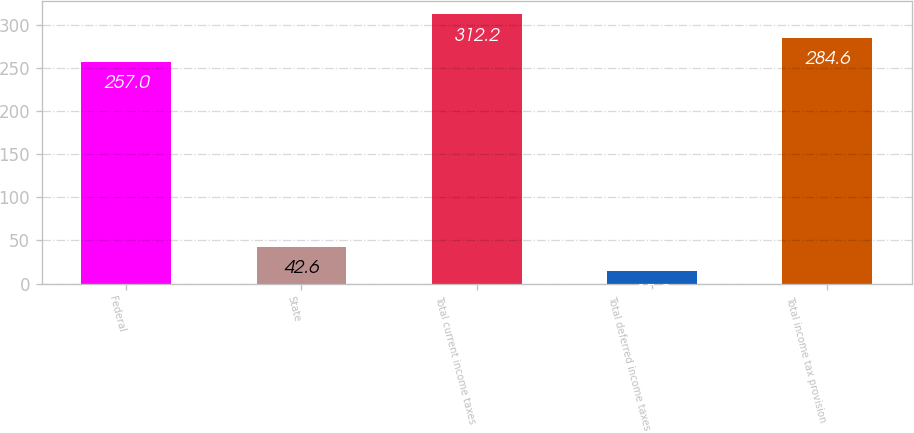Convert chart to OTSL. <chart><loc_0><loc_0><loc_500><loc_500><bar_chart><fcel>Federal<fcel>State<fcel>Total current income taxes<fcel>Total deferred income taxes<fcel>Total income tax provision<nl><fcel>257<fcel>42.6<fcel>312.2<fcel>15<fcel>284.6<nl></chart> 